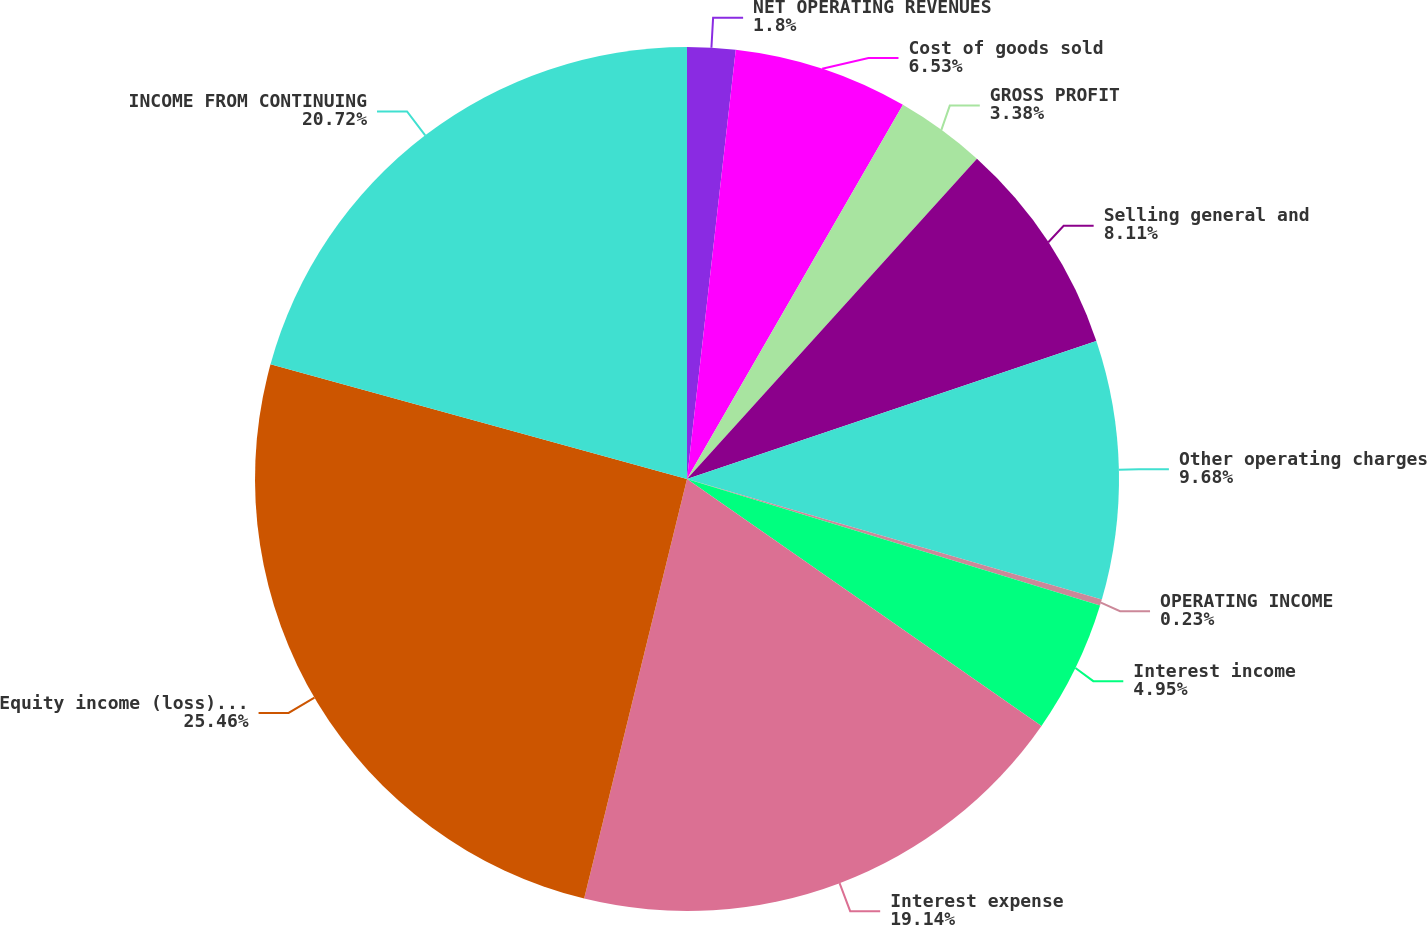<chart> <loc_0><loc_0><loc_500><loc_500><pie_chart><fcel>NET OPERATING REVENUES<fcel>Cost of goods sold<fcel>GROSS PROFIT<fcel>Selling general and<fcel>Other operating charges<fcel>OPERATING INCOME<fcel>Interest income<fcel>Interest expense<fcel>Equity income (loss) - net<fcel>INCOME FROM CONTINUING<nl><fcel>1.8%<fcel>6.53%<fcel>3.38%<fcel>8.11%<fcel>9.68%<fcel>0.23%<fcel>4.95%<fcel>19.14%<fcel>25.45%<fcel>20.72%<nl></chart> 